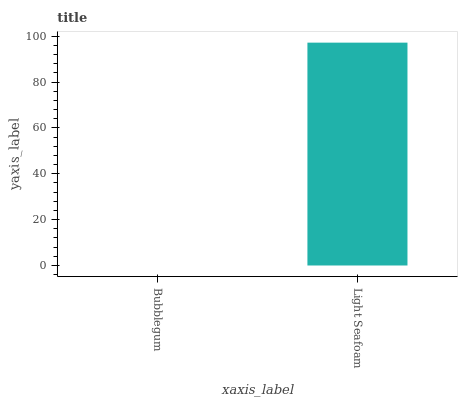Is Bubblegum the minimum?
Answer yes or no. Yes. Is Light Seafoam the maximum?
Answer yes or no. Yes. Is Light Seafoam the minimum?
Answer yes or no. No. Is Light Seafoam greater than Bubblegum?
Answer yes or no. Yes. Is Bubblegum less than Light Seafoam?
Answer yes or no. Yes. Is Bubblegum greater than Light Seafoam?
Answer yes or no. No. Is Light Seafoam less than Bubblegum?
Answer yes or no. No. Is Light Seafoam the high median?
Answer yes or no. Yes. Is Bubblegum the low median?
Answer yes or no. Yes. Is Bubblegum the high median?
Answer yes or no. No. Is Light Seafoam the low median?
Answer yes or no. No. 